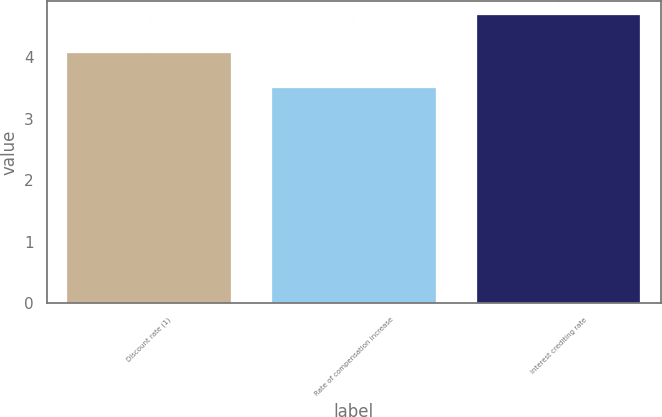Convert chart. <chart><loc_0><loc_0><loc_500><loc_500><bar_chart><fcel>Discount rate (1)<fcel>Rate of compensation increase<fcel>Interest crediting rate<nl><fcel>4.08<fcel>3.5<fcel>4.69<nl></chart> 